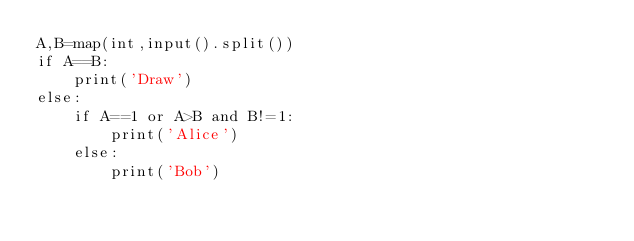Convert code to text. <code><loc_0><loc_0><loc_500><loc_500><_Python_>A,B=map(int,input().split())
if A==B:
    print('Draw')
else:
    if A==1 or A>B and B!=1:
        print('Alice')
    else:
        print('Bob')</code> 